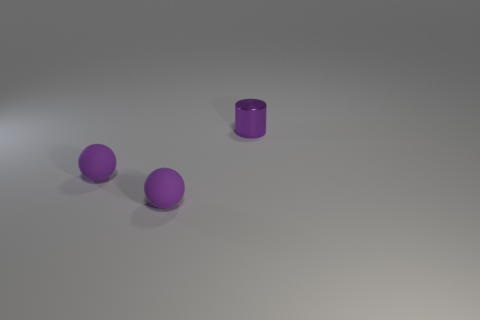Add 2 tiny balls. How many objects exist? 5 Subtract all balls. How many objects are left? 1 Subtract 0 blue cylinders. How many objects are left? 3 Subtract all metal balls. Subtract all purple metallic cylinders. How many objects are left? 2 Add 3 tiny purple rubber things. How many tiny purple rubber things are left? 5 Add 3 purple matte things. How many purple matte things exist? 5 